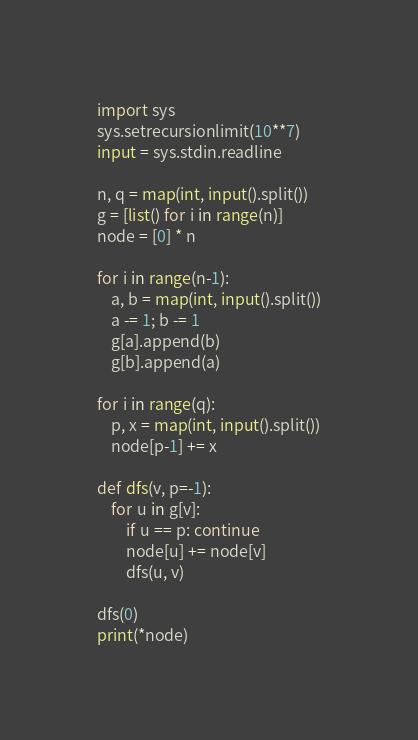Convert code to text. <code><loc_0><loc_0><loc_500><loc_500><_Python_>import sys
sys.setrecursionlimit(10**7)
input = sys.stdin.readline
 
n, q = map(int, input().split())
g = [list() for i in range(n)]
node = [0] * n
 
for i in range(n-1):
    a, b = map(int, input().split())
    a -= 1; b -= 1
    g[a].append(b)
    g[b].append(a)
 
for i in range(q):
    p, x = map(int, input().split())
    node[p-1] += x
 
def dfs(v, p=-1):
    for u in g[v]:
        if u == p: continue
        node[u] += node[v]
        dfs(u, v)
 
dfs(0)
print(*node)</code> 